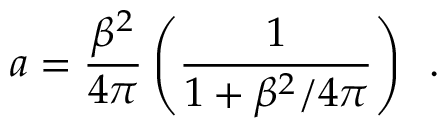<formula> <loc_0><loc_0><loc_500><loc_500>a = \frac { \beta ^ { 2 } } { 4 \pi } \left ( \frac { 1 } { 1 + \beta ^ { 2 } / 4 \pi } \right ) \, .</formula> 